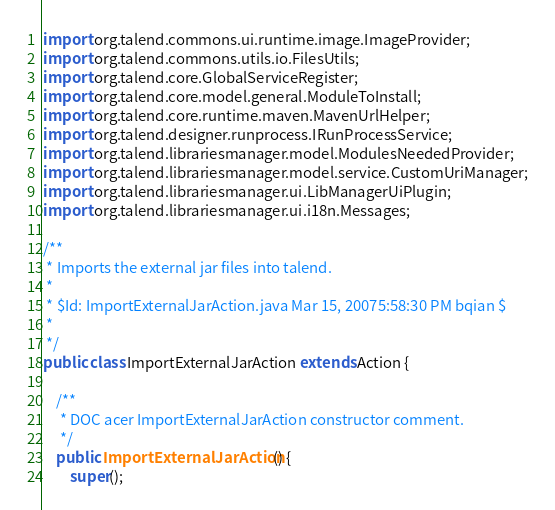Convert code to text. <code><loc_0><loc_0><loc_500><loc_500><_Java_>import org.talend.commons.ui.runtime.image.ImageProvider;
import org.talend.commons.utils.io.FilesUtils;
import org.talend.core.GlobalServiceRegister;
import org.talend.core.model.general.ModuleToInstall;
import org.talend.core.runtime.maven.MavenUrlHelper;
import org.talend.designer.runprocess.IRunProcessService;
import org.talend.librariesmanager.model.ModulesNeededProvider;
import org.talend.librariesmanager.model.service.CustomUriManager;
import org.talend.librariesmanager.ui.LibManagerUiPlugin;
import org.talend.librariesmanager.ui.i18n.Messages;

/**
 * Imports the external jar files into talend.
 *
 * $Id: ImportExternalJarAction.java Mar 15, 20075:58:30 PM bqian $
 *
 */
public class ImportExternalJarAction extends Action {

    /**
     * DOC acer ImportExternalJarAction constructor comment.
     */
    public ImportExternalJarAction() {
        super();</code> 